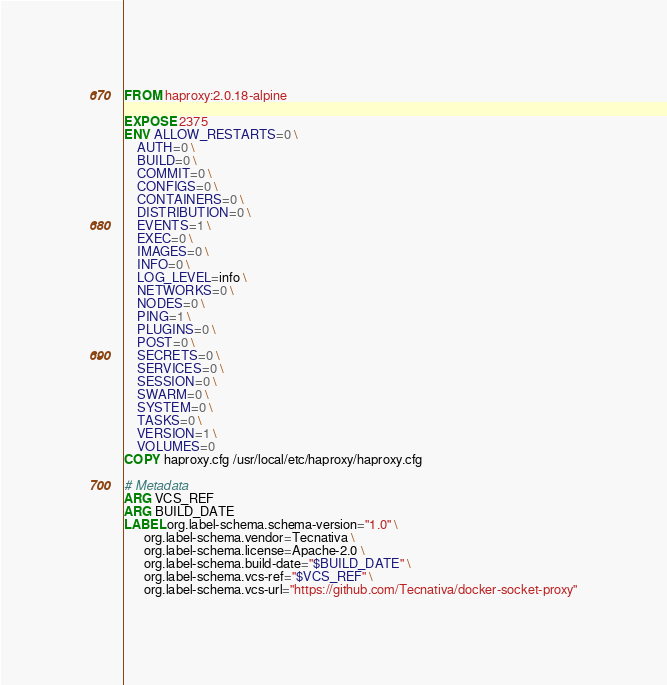Convert code to text. <code><loc_0><loc_0><loc_500><loc_500><_Dockerfile_>FROM haproxy:2.0.18-alpine

EXPOSE 2375
ENV ALLOW_RESTARTS=0 \
    AUTH=0 \
    BUILD=0 \
    COMMIT=0 \
    CONFIGS=0 \
    CONTAINERS=0 \
    DISTRIBUTION=0 \
    EVENTS=1 \
    EXEC=0 \
    IMAGES=0 \
    INFO=0 \
    LOG_LEVEL=info \
    NETWORKS=0 \
    NODES=0 \
    PING=1 \
    PLUGINS=0 \
    POST=0 \
    SECRETS=0 \
    SERVICES=0 \
    SESSION=0 \
    SWARM=0 \
    SYSTEM=0 \
    TASKS=0 \
    VERSION=1 \
    VOLUMES=0
COPY haproxy.cfg /usr/local/etc/haproxy/haproxy.cfg

# Metadata
ARG VCS_REF
ARG BUILD_DATE
LABEL org.label-schema.schema-version="1.0" \
      org.label-schema.vendor=Tecnativa \
      org.label-schema.license=Apache-2.0 \
      org.label-schema.build-date="$BUILD_DATE" \
      org.label-schema.vcs-ref="$VCS_REF" \
      org.label-schema.vcs-url="https://github.com/Tecnativa/docker-socket-proxy"
</code> 